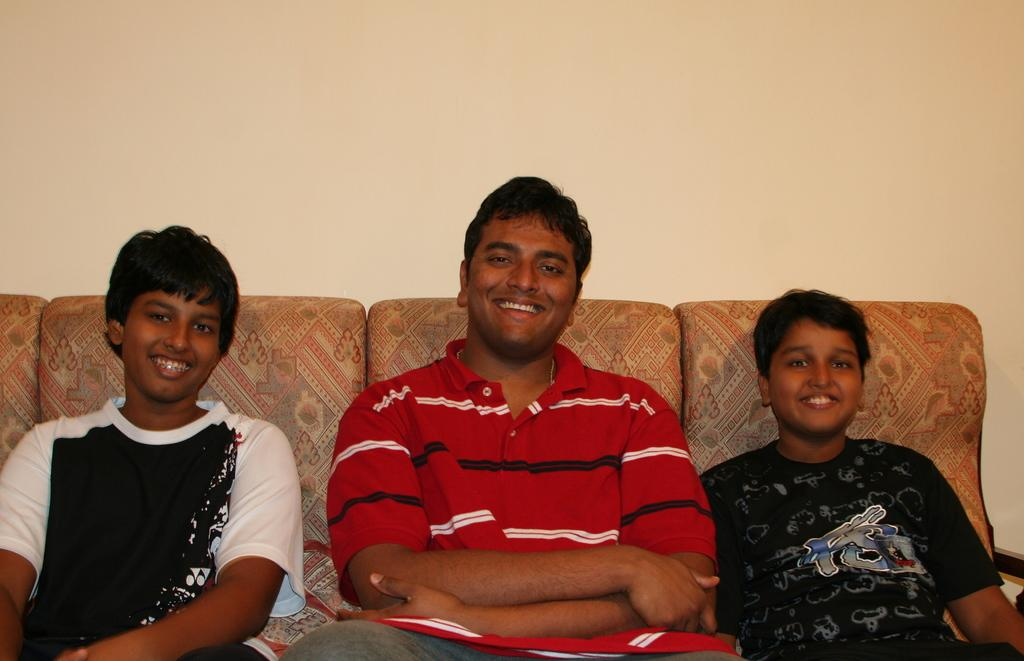Who is present in the image? There is a man and two children in the image. What are they doing in the image? The man and children are sitting on a sofa. What can be seen behind them in the image? There is a wall visible in the image. What type of crown is the man wearing in the image? There is no crown present in the image; the man is not wearing any headgear. How many women are visible in the image? There are no women visible in the image; only a man and two children are present. 